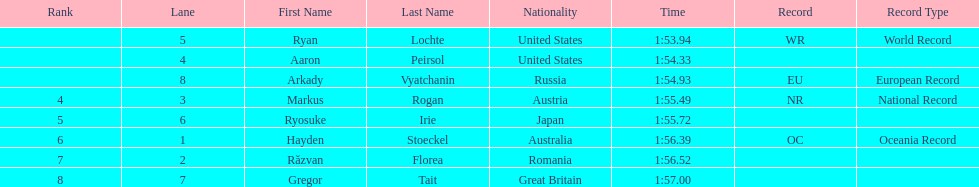How many swimmers were from the us? 2. 